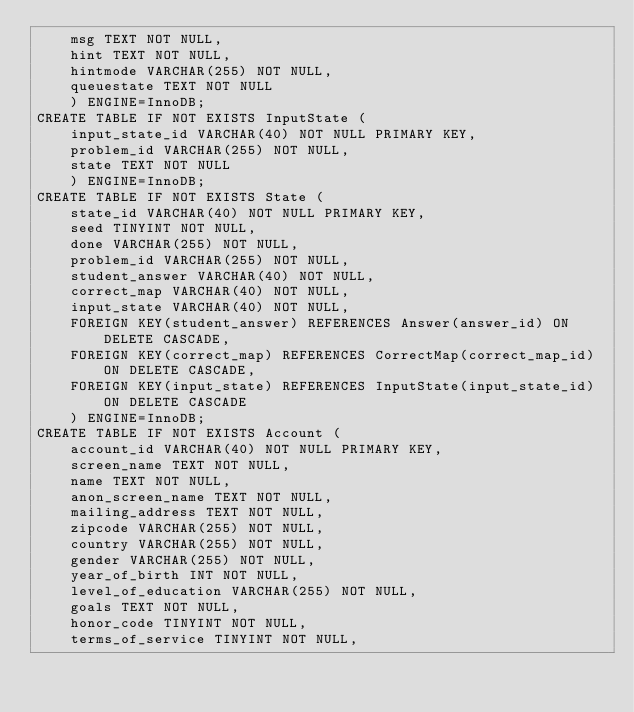<code> <loc_0><loc_0><loc_500><loc_500><_SQL_>    msg TEXT NOT NULL,
    hint TEXT NOT NULL,
    hintmode VARCHAR(255) NOT NULL,
    queuestate TEXT NOT NULL
    ) ENGINE=InnoDB;
CREATE TABLE IF NOT EXISTS InputState (
    input_state_id VARCHAR(40) NOT NULL PRIMARY KEY,
    problem_id VARCHAR(255) NOT NULL,
    state TEXT NOT NULL
    ) ENGINE=InnoDB;
CREATE TABLE IF NOT EXISTS State (
    state_id VARCHAR(40) NOT NULL PRIMARY KEY,
    seed TINYINT NOT NULL,
    done VARCHAR(255) NOT NULL,
    problem_id VARCHAR(255) NOT NULL,
    student_answer VARCHAR(40) NOT NULL,
    correct_map VARCHAR(40) NOT NULL,
    input_state VARCHAR(40) NOT NULL,
    FOREIGN KEY(student_answer) REFERENCES Answer(answer_id) ON DELETE CASCADE,
    FOREIGN KEY(correct_map) REFERENCES CorrectMap(correct_map_id) ON DELETE CASCADE,
    FOREIGN KEY(input_state) REFERENCES InputState(input_state_id) ON DELETE CASCADE
    ) ENGINE=InnoDB;
CREATE TABLE IF NOT EXISTS Account (
    account_id VARCHAR(40) NOT NULL PRIMARY KEY,
    screen_name TEXT NOT NULL,
    name TEXT NOT NULL,
    anon_screen_name TEXT NOT NULL,
    mailing_address TEXT NOT NULL,
    zipcode VARCHAR(255) NOT NULL,
    country VARCHAR(255) NOT NULL,
    gender VARCHAR(255) NOT NULL,
    year_of_birth INT NOT NULL,
    level_of_education VARCHAR(255) NOT NULL,
    goals TEXT NOT NULL,
    honor_code TINYINT NOT NULL,
    terms_of_service TINYINT NOT NULL,</code> 